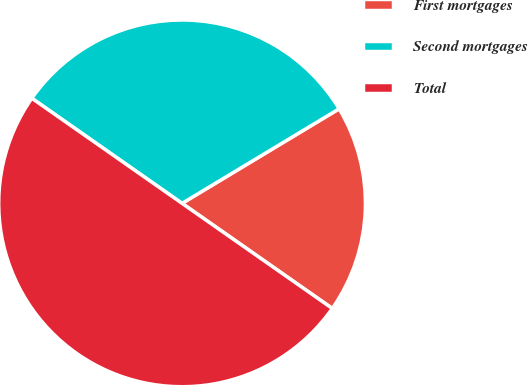<chart> <loc_0><loc_0><loc_500><loc_500><pie_chart><fcel>First mortgages<fcel>Second mortgages<fcel>Total<nl><fcel>18.34%<fcel>31.66%<fcel>50.0%<nl></chart> 